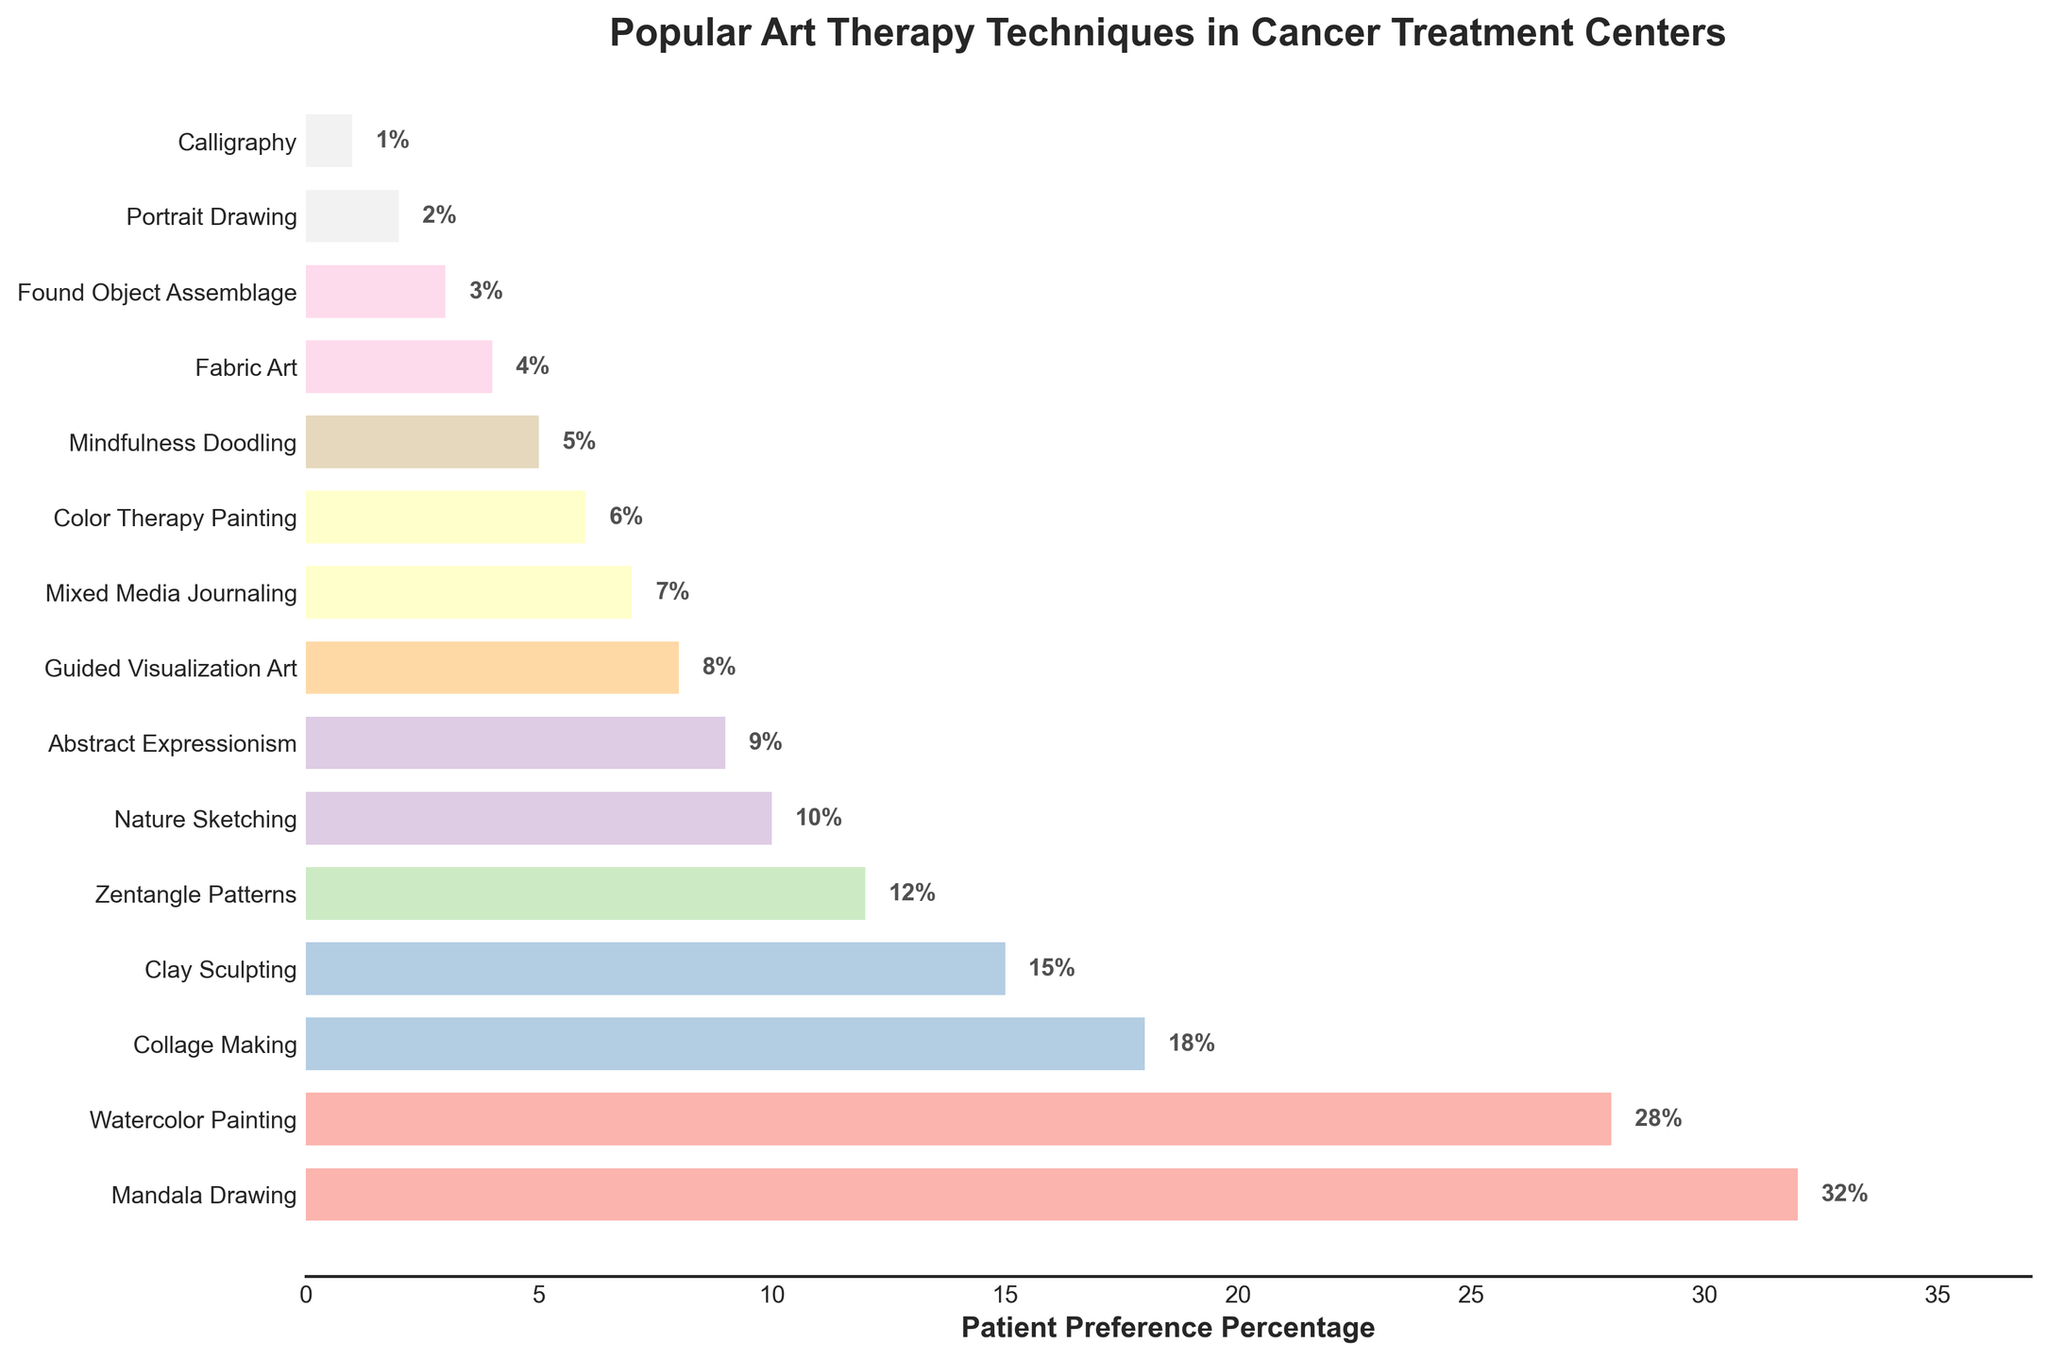Which art therapy technique has the highest patient preference? The bar with the longest length represents the highest preference. Mandala Drawing has the longest bar.
Answer: Mandala Drawing Which three art therapy techniques are the least preferred by patients? The shortest bars represent the least preferred techniques. The three shortest bars are for Calligraphy, Portrait Drawing, and Found Object Assemblage.
Answer: Calligraphy, Portrait Drawing, Found Object Assemblage What is the total percentage of patient preferences for the top five art therapy techniques? Sum the percentages of the top five bars: Mandala Drawing (32%), Watercolor Painting (28%), Collage Making (18%), Clay Sculpting (15%), Zentangle Patterns (12%). 32 + 28 + 18 + 15 + 12 = 105%
Answer: 105% Which art therapy technique is preferred by 28% of patients? Locate the bar with the label corresponding to 28%. The bar labeled Watercolor Painting matches this percentage.
Answer: Watercolor Painting How much more preferred is Mandala Drawing compared to Nature Sketching? Subtract the percentage of Nature Sketching (10%) from Mandala Drawing (32%). 32 - 10 = 22
Answer: 22% What is the combined percentage of preferences for Collage Making and Clay Sculpting? Add the percentages for Collage Making (18%) and Clay Sculpting (15%). 18 + 15 = 33%
Answer: 33% Is Guided Visualization Art preferred by more or fewer patients compared to Mixed Media Journaling? Compare the lengths of the bars for Guided Visualization Art (8%) and Mixed Media Journaling (7%). Guided Visualization Art has a greater length.
Answer: More Which technique has a preference closest to 7%? Identify the bar with a length closest to 7%. The bar for Mixed Media Journaling is labeled with 7%.
Answer: Mixed Media Journaling 